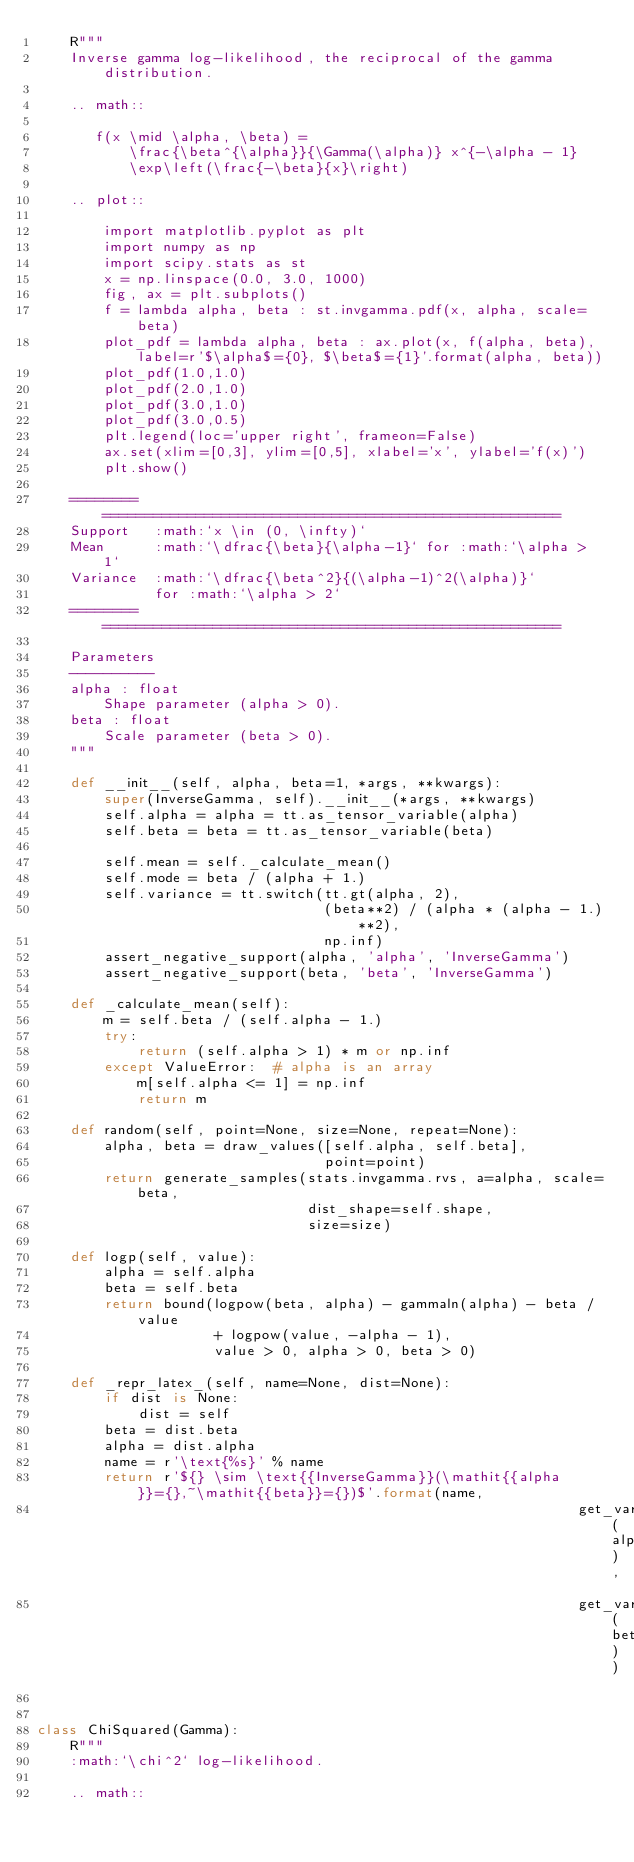<code> <loc_0><loc_0><loc_500><loc_500><_Python_>    R"""
    Inverse gamma log-likelihood, the reciprocal of the gamma distribution.

    .. math::

       f(x \mid \alpha, \beta) =
           \frac{\beta^{\alpha}}{\Gamma(\alpha)} x^{-\alpha - 1}
           \exp\left(\frac{-\beta}{x}\right)

    .. plot::

        import matplotlib.pyplot as plt
        import numpy as np
        import scipy.stats as st
        x = np.linspace(0.0, 3.0, 1000)
        fig, ax = plt.subplots()
        f = lambda alpha, beta : st.invgamma.pdf(x, alpha, scale=beta)
        plot_pdf = lambda alpha, beta : ax.plot(x, f(alpha, beta), label=r'$\alpha$={0}, $\beta$={1}'.format(alpha, beta))
        plot_pdf(1.0,1.0)
        plot_pdf(2.0,1.0)
        plot_pdf(3.0,1.0)
        plot_pdf(3.0,0.5)
        plt.legend(loc='upper right', frameon=False)
        ax.set(xlim=[0,3], ylim=[0,5], xlabel='x', ylabel='f(x)')
        plt.show()

    ========  ======================================================
    Support   :math:`x \in (0, \infty)`
    Mean      :math:`\dfrac{\beta}{\alpha-1}` for :math:`\alpha > 1`
    Variance  :math:`\dfrac{\beta^2}{(\alpha-1)^2(\alpha)}`
              for :math:`\alpha > 2`
    ========  ======================================================

    Parameters
    ----------
    alpha : float
        Shape parameter (alpha > 0).
    beta : float
        Scale parameter (beta > 0).
    """

    def __init__(self, alpha, beta=1, *args, **kwargs):
        super(InverseGamma, self).__init__(*args, **kwargs)
        self.alpha = alpha = tt.as_tensor_variable(alpha)
        self.beta = beta = tt.as_tensor_variable(beta)

        self.mean = self._calculate_mean()
        self.mode = beta / (alpha + 1.)
        self.variance = tt.switch(tt.gt(alpha, 2),
                                  (beta**2) / (alpha * (alpha - 1.)**2),
                                  np.inf)
        assert_negative_support(alpha, 'alpha', 'InverseGamma')
        assert_negative_support(beta, 'beta', 'InverseGamma')

    def _calculate_mean(self):
        m = self.beta / (self.alpha - 1.)
        try:
            return (self.alpha > 1) * m or np.inf
        except ValueError:  # alpha is an array
            m[self.alpha <= 1] = np.inf
            return m

    def random(self, point=None, size=None, repeat=None):
        alpha, beta = draw_values([self.alpha, self.beta],
                                  point=point)
        return generate_samples(stats.invgamma.rvs, a=alpha, scale=beta,
                                dist_shape=self.shape,
                                size=size)

    def logp(self, value):
        alpha = self.alpha
        beta = self.beta
        return bound(logpow(beta, alpha) - gammaln(alpha) - beta / value
                     + logpow(value, -alpha - 1),
                     value > 0, alpha > 0, beta > 0)

    def _repr_latex_(self, name=None, dist=None):
        if dist is None:
            dist = self
        beta = dist.beta
        alpha = dist.alpha
        name = r'\text{%s}' % name
        return r'${} \sim \text{{InverseGamma}}(\mathit{{alpha}}={},~\mathit{{beta}}={})$'.format(name,
                                                                get_variable_name(alpha),
                                                                get_variable_name(beta))


class ChiSquared(Gamma):
    R"""
    :math:`\chi^2` log-likelihood.

    .. math::
</code> 